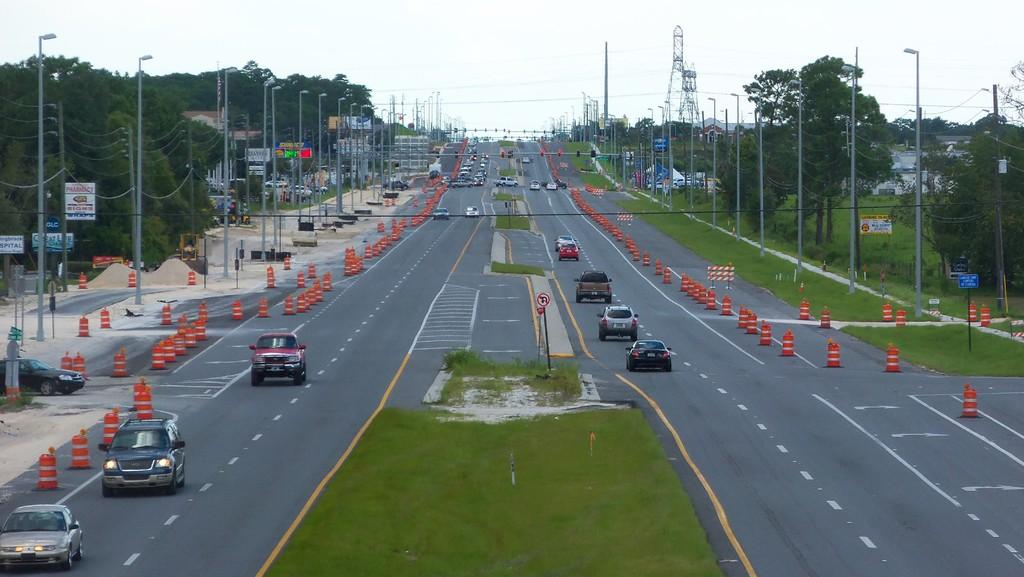What type of infrastructure can be seen in the image? There are roads in the image. What is happening on the roads? Cars are moving on the roads. What type of lighting is present along the roads? There are street lights visible. What type of vegetation can be seen in the image? Trees are present in the image. What is visible at the top of the image? The sky is visible at the top of the image. What type of stocking is hanging from the street light in the image? There is no stocking hanging from the street light in the image. How does the mint affect the grip of the cars on the roads in the image? There is no mint present in the image, and therefore it cannot affect the grip of the cars on the roads. 